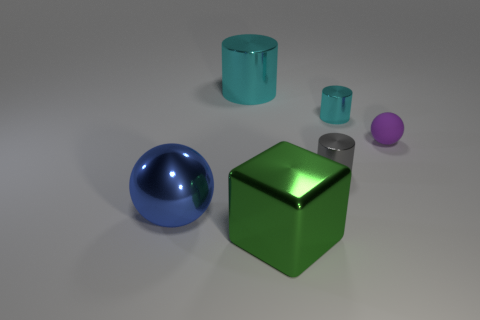Subtract all small cylinders. How many cylinders are left? 1 Subtract 2 cylinders. How many cylinders are left? 1 Subtract all green balls. How many cyan cylinders are left? 2 Subtract all gray cylinders. How many cylinders are left? 2 Add 3 large purple metallic things. How many objects exist? 9 Subtract all yellow cylinders. Subtract all cyan blocks. How many cylinders are left? 3 Add 4 shiny things. How many shiny things are left? 9 Add 6 gray rubber blocks. How many gray rubber blocks exist? 6 Subtract 0 gray balls. How many objects are left? 6 Subtract all blocks. How many objects are left? 5 